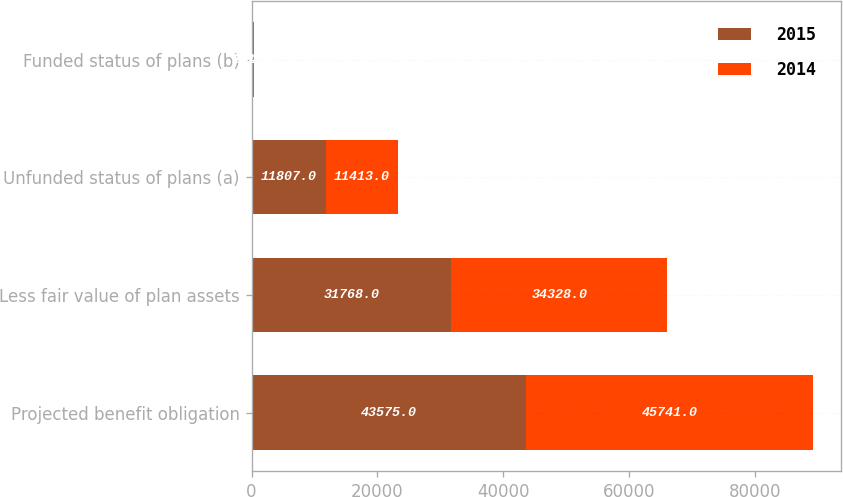Convert chart. <chart><loc_0><loc_0><loc_500><loc_500><stacked_bar_chart><ecel><fcel>Projected benefit obligation<fcel>Less fair value of plan assets<fcel>Unfunded status of plans (a)<fcel>Funded status of plans (b)<nl><fcel>2015<fcel>43575<fcel>31768<fcel>11807<fcel>201<nl><fcel>2014<fcel>45741<fcel>34328<fcel>11413<fcel>204<nl></chart> 